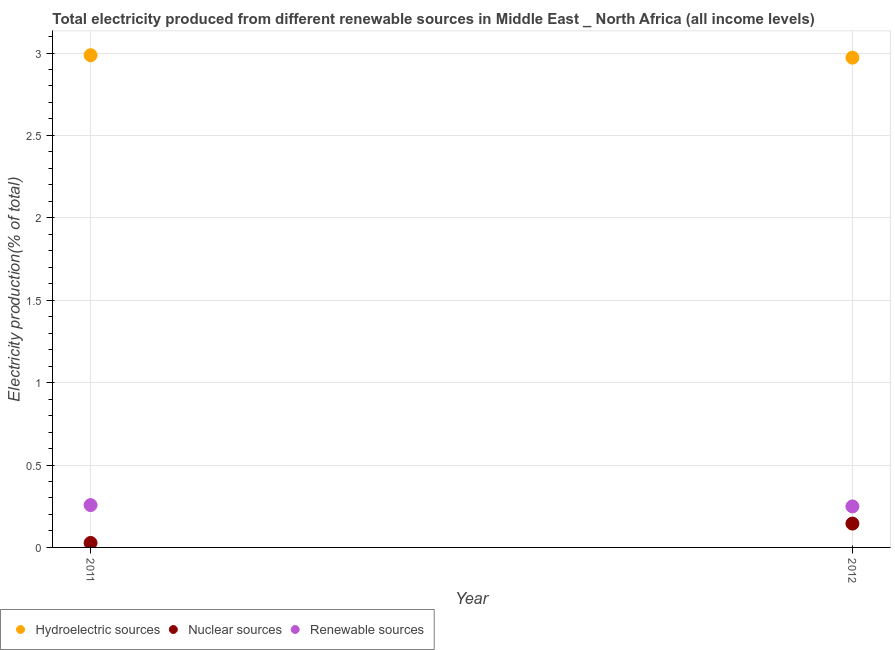Is the number of dotlines equal to the number of legend labels?
Provide a short and direct response. Yes. What is the percentage of electricity produced by hydroelectric sources in 2012?
Keep it short and to the point. 2.97. Across all years, what is the maximum percentage of electricity produced by nuclear sources?
Your answer should be compact. 0.14. Across all years, what is the minimum percentage of electricity produced by nuclear sources?
Give a very brief answer. 0.03. In which year was the percentage of electricity produced by hydroelectric sources minimum?
Provide a succinct answer. 2012. What is the total percentage of electricity produced by nuclear sources in the graph?
Make the answer very short. 0.17. What is the difference between the percentage of electricity produced by renewable sources in 2011 and that in 2012?
Make the answer very short. 0.01. What is the difference between the percentage of electricity produced by nuclear sources in 2011 and the percentage of electricity produced by renewable sources in 2012?
Give a very brief answer. -0.22. What is the average percentage of electricity produced by nuclear sources per year?
Keep it short and to the point. 0.09. In the year 2011, what is the difference between the percentage of electricity produced by renewable sources and percentage of electricity produced by hydroelectric sources?
Provide a short and direct response. -2.73. In how many years, is the percentage of electricity produced by nuclear sources greater than 2.7 %?
Your response must be concise. 0. What is the ratio of the percentage of electricity produced by nuclear sources in 2011 to that in 2012?
Make the answer very short. 0.19. Is the percentage of electricity produced by hydroelectric sources in 2011 less than that in 2012?
Make the answer very short. No. In how many years, is the percentage of electricity produced by hydroelectric sources greater than the average percentage of electricity produced by hydroelectric sources taken over all years?
Offer a very short reply. 1. Is it the case that in every year, the sum of the percentage of electricity produced by hydroelectric sources and percentage of electricity produced by nuclear sources is greater than the percentage of electricity produced by renewable sources?
Make the answer very short. Yes. Is the percentage of electricity produced by renewable sources strictly less than the percentage of electricity produced by hydroelectric sources over the years?
Provide a succinct answer. Yes. How many years are there in the graph?
Keep it short and to the point. 2. What is the difference between two consecutive major ticks on the Y-axis?
Keep it short and to the point. 0.5. Where does the legend appear in the graph?
Offer a very short reply. Bottom left. How many legend labels are there?
Keep it short and to the point. 3. What is the title of the graph?
Ensure brevity in your answer.  Total electricity produced from different renewable sources in Middle East _ North Africa (all income levels). What is the label or title of the X-axis?
Offer a very short reply. Year. What is the Electricity production(% of total) in Hydroelectric sources in 2011?
Your answer should be compact. 2.99. What is the Electricity production(% of total) of Nuclear sources in 2011?
Provide a short and direct response. 0.03. What is the Electricity production(% of total) in Renewable sources in 2011?
Your answer should be very brief. 0.26. What is the Electricity production(% of total) in Hydroelectric sources in 2012?
Offer a very short reply. 2.97. What is the Electricity production(% of total) in Nuclear sources in 2012?
Your response must be concise. 0.14. What is the Electricity production(% of total) in Renewable sources in 2012?
Your response must be concise. 0.25. Across all years, what is the maximum Electricity production(% of total) in Hydroelectric sources?
Provide a short and direct response. 2.99. Across all years, what is the maximum Electricity production(% of total) in Nuclear sources?
Offer a very short reply. 0.14. Across all years, what is the maximum Electricity production(% of total) of Renewable sources?
Provide a succinct answer. 0.26. Across all years, what is the minimum Electricity production(% of total) in Hydroelectric sources?
Offer a terse response. 2.97. Across all years, what is the minimum Electricity production(% of total) in Nuclear sources?
Give a very brief answer. 0.03. Across all years, what is the minimum Electricity production(% of total) in Renewable sources?
Your answer should be compact. 0.25. What is the total Electricity production(% of total) in Hydroelectric sources in the graph?
Provide a succinct answer. 5.96. What is the total Electricity production(% of total) of Nuclear sources in the graph?
Offer a terse response. 0.17. What is the total Electricity production(% of total) of Renewable sources in the graph?
Keep it short and to the point. 0.51. What is the difference between the Electricity production(% of total) in Hydroelectric sources in 2011 and that in 2012?
Your answer should be compact. 0.01. What is the difference between the Electricity production(% of total) of Nuclear sources in 2011 and that in 2012?
Offer a terse response. -0.12. What is the difference between the Electricity production(% of total) of Renewable sources in 2011 and that in 2012?
Your response must be concise. 0.01. What is the difference between the Electricity production(% of total) of Hydroelectric sources in 2011 and the Electricity production(% of total) of Nuclear sources in 2012?
Provide a succinct answer. 2.84. What is the difference between the Electricity production(% of total) in Hydroelectric sources in 2011 and the Electricity production(% of total) in Renewable sources in 2012?
Give a very brief answer. 2.74. What is the difference between the Electricity production(% of total) in Nuclear sources in 2011 and the Electricity production(% of total) in Renewable sources in 2012?
Offer a very short reply. -0.22. What is the average Electricity production(% of total) in Hydroelectric sources per year?
Give a very brief answer. 2.98. What is the average Electricity production(% of total) of Nuclear sources per year?
Provide a short and direct response. 0.09. What is the average Electricity production(% of total) of Renewable sources per year?
Offer a terse response. 0.25. In the year 2011, what is the difference between the Electricity production(% of total) of Hydroelectric sources and Electricity production(% of total) of Nuclear sources?
Provide a short and direct response. 2.96. In the year 2011, what is the difference between the Electricity production(% of total) of Hydroelectric sources and Electricity production(% of total) of Renewable sources?
Offer a terse response. 2.73. In the year 2011, what is the difference between the Electricity production(% of total) of Nuclear sources and Electricity production(% of total) of Renewable sources?
Provide a succinct answer. -0.23. In the year 2012, what is the difference between the Electricity production(% of total) of Hydroelectric sources and Electricity production(% of total) of Nuclear sources?
Offer a very short reply. 2.83. In the year 2012, what is the difference between the Electricity production(% of total) in Hydroelectric sources and Electricity production(% of total) in Renewable sources?
Keep it short and to the point. 2.72. In the year 2012, what is the difference between the Electricity production(% of total) of Nuclear sources and Electricity production(% of total) of Renewable sources?
Your answer should be compact. -0.1. What is the ratio of the Electricity production(% of total) in Hydroelectric sources in 2011 to that in 2012?
Your answer should be compact. 1. What is the ratio of the Electricity production(% of total) in Nuclear sources in 2011 to that in 2012?
Offer a very short reply. 0.19. What is the ratio of the Electricity production(% of total) in Renewable sources in 2011 to that in 2012?
Your response must be concise. 1.03. What is the difference between the highest and the second highest Electricity production(% of total) of Hydroelectric sources?
Your response must be concise. 0.01. What is the difference between the highest and the second highest Electricity production(% of total) in Nuclear sources?
Your answer should be very brief. 0.12. What is the difference between the highest and the second highest Electricity production(% of total) in Renewable sources?
Your answer should be compact. 0.01. What is the difference between the highest and the lowest Electricity production(% of total) in Hydroelectric sources?
Your answer should be very brief. 0.01. What is the difference between the highest and the lowest Electricity production(% of total) of Nuclear sources?
Offer a terse response. 0.12. What is the difference between the highest and the lowest Electricity production(% of total) in Renewable sources?
Give a very brief answer. 0.01. 